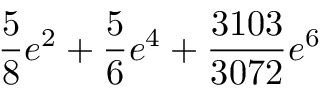Convert formula to latex. <formula><loc_0><loc_0><loc_500><loc_500>\frac { 5 } { 8 } e ^ { 2 } + \frac { 5 } { 6 } e ^ { 4 } + \frac { 3 1 0 3 } { 3 0 7 2 } e ^ { 6 }</formula> 